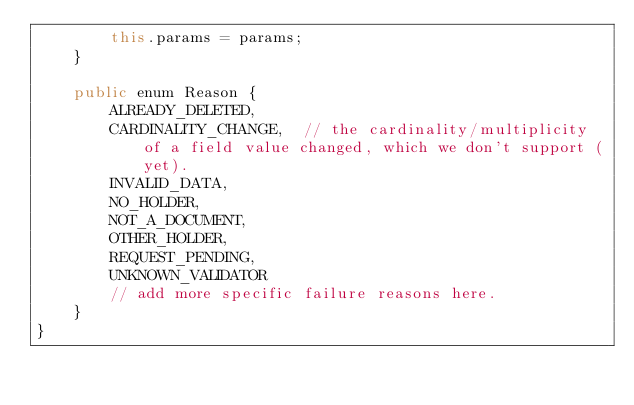<code> <loc_0><loc_0><loc_500><loc_500><_Java_>        this.params = params;
    }

    public enum Reason {
        ALREADY_DELETED,
        CARDINALITY_CHANGE,  // the cardinality/multiplicity of a field value changed, which we don't support (yet).
        INVALID_DATA,
        NO_HOLDER,
        NOT_A_DOCUMENT,
        OTHER_HOLDER,
        REQUEST_PENDING,
        UNKNOWN_VALIDATOR
        // add more specific failure reasons here.
    }
}
</code> 